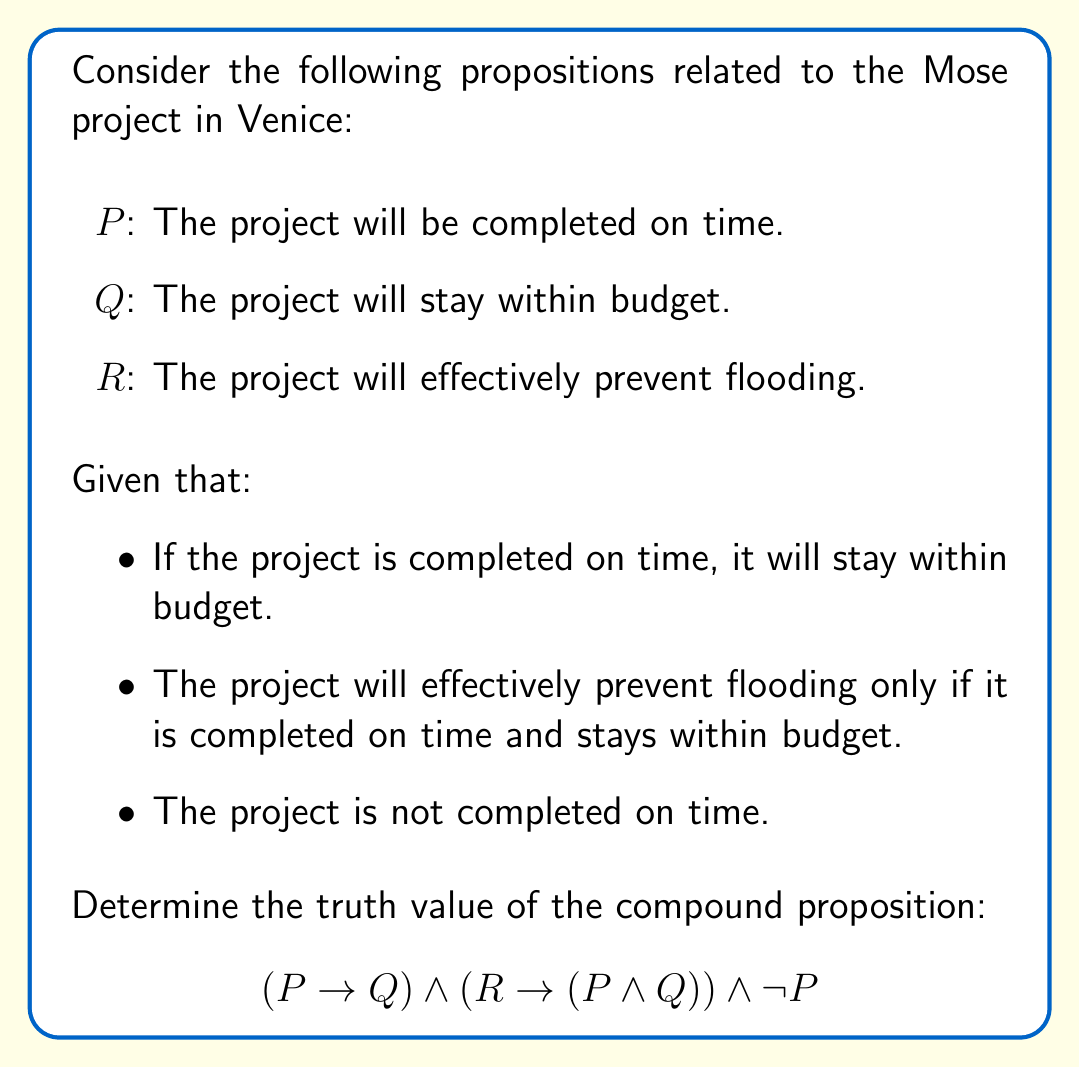Solve this math problem. Let's evaluate this compound proposition step by step:

1. First, let's consider the given information:
   - $P \rightarrow Q$ (If the project is completed on time, it will stay within budget)
   - $R \rightarrow (P \land Q)$ (The project will effectively prevent flooding only if it is completed on time and stays within budget)
   - $\lnot P$ (The project is not completed on time)

2. Now, let's evaluate each part of the compound proposition:

   a) $P \rightarrow Q$:
      Since $P$ is false (given $\lnot P$), the implication $P \rightarrow Q$ is always true, regardless of the truth value of $Q$. This is because a false antecedent always results in a true implication.

   b) $R \rightarrow (P \land Q)$:
      We don't know the truth value of $R$, but we know that $P$ is false. Since $P \land Q$ contains $P$, and $P$ is false, $P \land Q$ is always false. Therefore, $R \rightarrow (P \land Q)$ is true when $R$ is false, and false when $R$ is true.

   c) $\lnot P$:
      This is given as true in the problem statement.

3. Now, we can combine these results:
   $$(P \rightarrow Q) \land (R \rightarrow (P \land Q)) \land \lnot P$$
   $$(T) \land (T \text{ or } F) \land (T)$$

   The middle term $(R \rightarrow (P \land Q))$ could be true or false, but it doesn't affect the overall result because:
   - If it's true: $T \land T \land T = T$
   - If it's false: $T \land F \land T = F$

4. Therefore, the truth value of the entire compound proposition depends on the truth value of $R$:
   - If $R$ is false, the compound proposition is true.
   - If $R$ is true, the compound proposition is false.

However, given the context of the Mose project and the fact that it's not completed on time (and thus likely not within budget), it's reasonable to assume that $R$ (the project will effectively prevent flooding) is false.
Answer: The compound proposition is most likely true, assuming that the project will not effectively prevent flooding due to delays and potential budget overruns. 